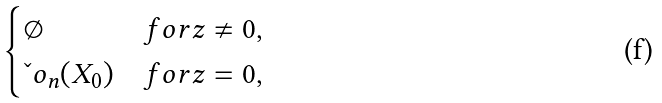Convert formula to latex. <formula><loc_0><loc_0><loc_500><loc_500>\begin{cases} \emptyset & f o r z \neq 0 , \\ \L o _ { n } ( X _ { 0 } ) & f o r z = 0 , \end{cases}</formula> 